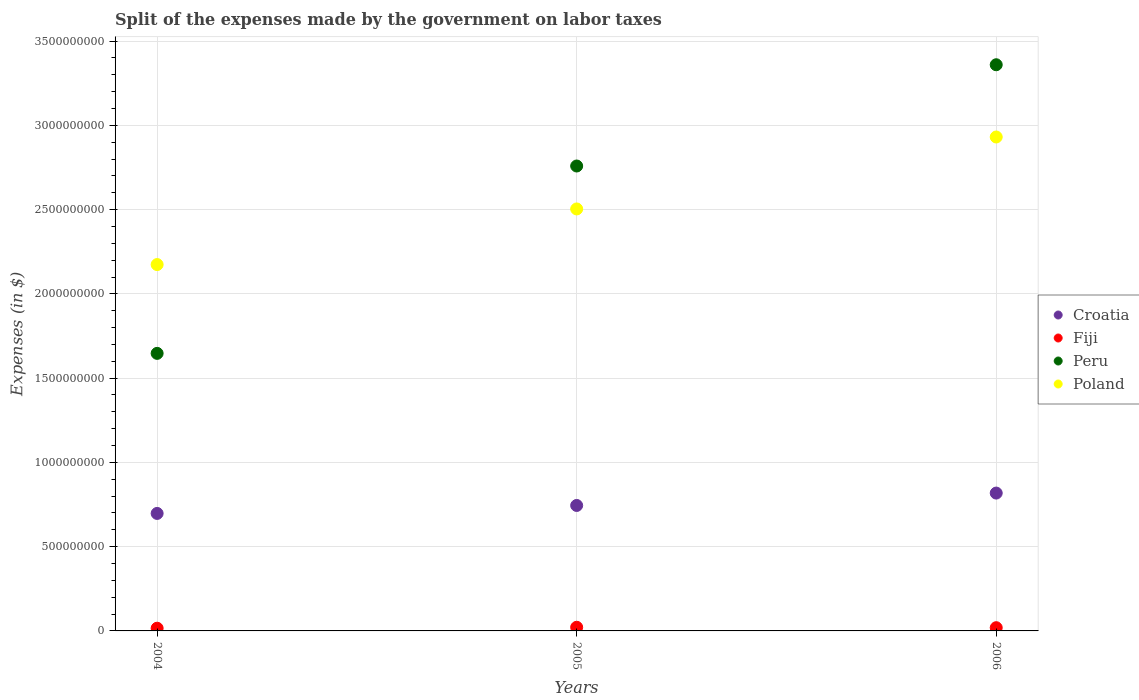How many different coloured dotlines are there?
Provide a succinct answer. 4. Is the number of dotlines equal to the number of legend labels?
Offer a terse response. Yes. What is the expenses made by the government on labor taxes in Peru in 2006?
Make the answer very short. 3.36e+09. Across all years, what is the maximum expenses made by the government on labor taxes in Poland?
Provide a short and direct response. 2.93e+09. Across all years, what is the minimum expenses made by the government on labor taxes in Croatia?
Provide a succinct answer. 6.97e+08. In which year was the expenses made by the government on labor taxes in Poland maximum?
Provide a succinct answer. 2006. What is the total expenses made by the government on labor taxes in Peru in the graph?
Provide a short and direct response. 7.77e+09. What is the difference between the expenses made by the government on labor taxes in Croatia in 2005 and that in 2006?
Your response must be concise. -7.35e+07. What is the difference between the expenses made by the government on labor taxes in Poland in 2004 and the expenses made by the government on labor taxes in Peru in 2005?
Give a very brief answer. -5.85e+08. What is the average expenses made by the government on labor taxes in Fiji per year?
Your answer should be very brief. 1.90e+07. In the year 2005, what is the difference between the expenses made by the government on labor taxes in Peru and expenses made by the government on labor taxes in Poland?
Your answer should be compact. 2.55e+08. In how many years, is the expenses made by the government on labor taxes in Poland greater than 1600000000 $?
Provide a short and direct response. 3. What is the ratio of the expenses made by the government on labor taxes in Poland in 2004 to that in 2006?
Your response must be concise. 0.74. Is the difference between the expenses made by the government on labor taxes in Peru in 2004 and 2006 greater than the difference between the expenses made by the government on labor taxes in Poland in 2004 and 2006?
Your response must be concise. No. What is the difference between the highest and the second highest expenses made by the government on labor taxes in Poland?
Ensure brevity in your answer.  4.27e+08. What is the difference between the highest and the lowest expenses made by the government on labor taxes in Fiji?
Your response must be concise. 5.63e+06. Does the expenses made by the government on labor taxes in Poland monotonically increase over the years?
Give a very brief answer. Yes. How many dotlines are there?
Make the answer very short. 4. What is the difference between two consecutive major ticks on the Y-axis?
Provide a succinct answer. 5.00e+08. Where does the legend appear in the graph?
Offer a terse response. Center right. How many legend labels are there?
Your response must be concise. 4. What is the title of the graph?
Offer a terse response. Split of the expenses made by the government on labor taxes. Does "Middle income" appear as one of the legend labels in the graph?
Make the answer very short. No. What is the label or title of the X-axis?
Provide a succinct answer. Years. What is the label or title of the Y-axis?
Your answer should be compact. Expenses (in $). What is the Expenses (in $) in Croatia in 2004?
Your response must be concise. 6.97e+08. What is the Expenses (in $) of Fiji in 2004?
Your response must be concise. 1.61e+07. What is the Expenses (in $) in Peru in 2004?
Your response must be concise. 1.65e+09. What is the Expenses (in $) of Poland in 2004?
Keep it short and to the point. 2.17e+09. What is the Expenses (in $) of Croatia in 2005?
Make the answer very short. 7.44e+08. What is the Expenses (in $) of Fiji in 2005?
Your answer should be very brief. 2.17e+07. What is the Expenses (in $) in Peru in 2005?
Your answer should be very brief. 2.76e+09. What is the Expenses (in $) of Poland in 2005?
Provide a short and direct response. 2.50e+09. What is the Expenses (in $) of Croatia in 2006?
Give a very brief answer. 8.18e+08. What is the Expenses (in $) in Fiji in 2006?
Your response must be concise. 1.92e+07. What is the Expenses (in $) in Peru in 2006?
Make the answer very short. 3.36e+09. What is the Expenses (in $) in Poland in 2006?
Make the answer very short. 2.93e+09. Across all years, what is the maximum Expenses (in $) of Croatia?
Your answer should be compact. 8.18e+08. Across all years, what is the maximum Expenses (in $) in Fiji?
Your answer should be very brief. 2.17e+07. Across all years, what is the maximum Expenses (in $) in Peru?
Offer a very short reply. 3.36e+09. Across all years, what is the maximum Expenses (in $) of Poland?
Provide a short and direct response. 2.93e+09. Across all years, what is the minimum Expenses (in $) in Croatia?
Ensure brevity in your answer.  6.97e+08. Across all years, what is the minimum Expenses (in $) of Fiji?
Offer a very short reply. 1.61e+07. Across all years, what is the minimum Expenses (in $) of Peru?
Keep it short and to the point. 1.65e+09. Across all years, what is the minimum Expenses (in $) of Poland?
Your answer should be compact. 2.17e+09. What is the total Expenses (in $) of Croatia in the graph?
Your answer should be compact. 2.26e+09. What is the total Expenses (in $) in Fiji in the graph?
Your response must be concise. 5.69e+07. What is the total Expenses (in $) of Peru in the graph?
Your answer should be compact. 7.77e+09. What is the total Expenses (in $) in Poland in the graph?
Keep it short and to the point. 7.61e+09. What is the difference between the Expenses (in $) of Croatia in 2004 and that in 2005?
Ensure brevity in your answer.  -4.73e+07. What is the difference between the Expenses (in $) of Fiji in 2004 and that in 2005?
Your response must be concise. -5.63e+06. What is the difference between the Expenses (in $) of Peru in 2004 and that in 2005?
Your answer should be very brief. -1.11e+09. What is the difference between the Expenses (in $) in Poland in 2004 and that in 2005?
Offer a terse response. -3.30e+08. What is the difference between the Expenses (in $) of Croatia in 2004 and that in 2006?
Offer a terse response. -1.21e+08. What is the difference between the Expenses (in $) of Fiji in 2004 and that in 2006?
Keep it short and to the point. -3.12e+06. What is the difference between the Expenses (in $) in Peru in 2004 and that in 2006?
Ensure brevity in your answer.  -1.71e+09. What is the difference between the Expenses (in $) of Poland in 2004 and that in 2006?
Provide a short and direct response. -7.57e+08. What is the difference between the Expenses (in $) of Croatia in 2005 and that in 2006?
Your answer should be very brief. -7.35e+07. What is the difference between the Expenses (in $) of Fiji in 2005 and that in 2006?
Make the answer very short. 2.51e+06. What is the difference between the Expenses (in $) of Peru in 2005 and that in 2006?
Provide a succinct answer. -6.01e+08. What is the difference between the Expenses (in $) in Poland in 2005 and that in 2006?
Give a very brief answer. -4.27e+08. What is the difference between the Expenses (in $) in Croatia in 2004 and the Expenses (in $) in Fiji in 2005?
Offer a very short reply. 6.76e+08. What is the difference between the Expenses (in $) in Croatia in 2004 and the Expenses (in $) in Peru in 2005?
Offer a terse response. -2.06e+09. What is the difference between the Expenses (in $) in Croatia in 2004 and the Expenses (in $) in Poland in 2005?
Your answer should be very brief. -1.81e+09. What is the difference between the Expenses (in $) of Fiji in 2004 and the Expenses (in $) of Peru in 2005?
Offer a terse response. -2.74e+09. What is the difference between the Expenses (in $) of Fiji in 2004 and the Expenses (in $) of Poland in 2005?
Provide a short and direct response. -2.49e+09. What is the difference between the Expenses (in $) of Peru in 2004 and the Expenses (in $) of Poland in 2005?
Provide a short and direct response. -8.57e+08. What is the difference between the Expenses (in $) in Croatia in 2004 and the Expenses (in $) in Fiji in 2006?
Provide a succinct answer. 6.78e+08. What is the difference between the Expenses (in $) in Croatia in 2004 and the Expenses (in $) in Peru in 2006?
Ensure brevity in your answer.  -2.66e+09. What is the difference between the Expenses (in $) in Croatia in 2004 and the Expenses (in $) in Poland in 2006?
Keep it short and to the point. -2.23e+09. What is the difference between the Expenses (in $) in Fiji in 2004 and the Expenses (in $) in Peru in 2006?
Offer a very short reply. -3.34e+09. What is the difference between the Expenses (in $) of Fiji in 2004 and the Expenses (in $) of Poland in 2006?
Give a very brief answer. -2.91e+09. What is the difference between the Expenses (in $) of Peru in 2004 and the Expenses (in $) of Poland in 2006?
Make the answer very short. -1.28e+09. What is the difference between the Expenses (in $) in Croatia in 2005 and the Expenses (in $) in Fiji in 2006?
Ensure brevity in your answer.  7.25e+08. What is the difference between the Expenses (in $) of Croatia in 2005 and the Expenses (in $) of Peru in 2006?
Offer a terse response. -2.62e+09. What is the difference between the Expenses (in $) of Croatia in 2005 and the Expenses (in $) of Poland in 2006?
Offer a terse response. -2.19e+09. What is the difference between the Expenses (in $) in Fiji in 2005 and the Expenses (in $) in Peru in 2006?
Make the answer very short. -3.34e+09. What is the difference between the Expenses (in $) in Fiji in 2005 and the Expenses (in $) in Poland in 2006?
Make the answer very short. -2.91e+09. What is the difference between the Expenses (in $) in Peru in 2005 and the Expenses (in $) in Poland in 2006?
Your answer should be compact. -1.72e+08. What is the average Expenses (in $) in Croatia per year?
Provide a succinct answer. 7.53e+08. What is the average Expenses (in $) in Fiji per year?
Ensure brevity in your answer.  1.90e+07. What is the average Expenses (in $) of Peru per year?
Provide a short and direct response. 2.59e+09. What is the average Expenses (in $) in Poland per year?
Provide a succinct answer. 2.54e+09. In the year 2004, what is the difference between the Expenses (in $) in Croatia and Expenses (in $) in Fiji?
Offer a terse response. 6.81e+08. In the year 2004, what is the difference between the Expenses (in $) in Croatia and Expenses (in $) in Peru?
Your answer should be very brief. -9.50e+08. In the year 2004, what is the difference between the Expenses (in $) of Croatia and Expenses (in $) of Poland?
Ensure brevity in your answer.  -1.48e+09. In the year 2004, what is the difference between the Expenses (in $) in Fiji and Expenses (in $) in Peru?
Keep it short and to the point. -1.63e+09. In the year 2004, what is the difference between the Expenses (in $) in Fiji and Expenses (in $) in Poland?
Give a very brief answer. -2.16e+09. In the year 2004, what is the difference between the Expenses (in $) in Peru and Expenses (in $) in Poland?
Ensure brevity in your answer.  -5.27e+08. In the year 2005, what is the difference between the Expenses (in $) in Croatia and Expenses (in $) in Fiji?
Give a very brief answer. 7.23e+08. In the year 2005, what is the difference between the Expenses (in $) in Croatia and Expenses (in $) in Peru?
Offer a very short reply. -2.01e+09. In the year 2005, what is the difference between the Expenses (in $) in Croatia and Expenses (in $) in Poland?
Offer a terse response. -1.76e+09. In the year 2005, what is the difference between the Expenses (in $) of Fiji and Expenses (in $) of Peru?
Keep it short and to the point. -2.74e+09. In the year 2005, what is the difference between the Expenses (in $) in Fiji and Expenses (in $) in Poland?
Your answer should be very brief. -2.48e+09. In the year 2005, what is the difference between the Expenses (in $) in Peru and Expenses (in $) in Poland?
Provide a short and direct response. 2.55e+08. In the year 2006, what is the difference between the Expenses (in $) of Croatia and Expenses (in $) of Fiji?
Your answer should be compact. 7.99e+08. In the year 2006, what is the difference between the Expenses (in $) in Croatia and Expenses (in $) in Peru?
Keep it short and to the point. -2.54e+09. In the year 2006, what is the difference between the Expenses (in $) in Croatia and Expenses (in $) in Poland?
Provide a short and direct response. -2.11e+09. In the year 2006, what is the difference between the Expenses (in $) in Fiji and Expenses (in $) in Peru?
Provide a short and direct response. -3.34e+09. In the year 2006, what is the difference between the Expenses (in $) in Fiji and Expenses (in $) in Poland?
Offer a terse response. -2.91e+09. In the year 2006, what is the difference between the Expenses (in $) in Peru and Expenses (in $) in Poland?
Ensure brevity in your answer.  4.29e+08. What is the ratio of the Expenses (in $) of Croatia in 2004 to that in 2005?
Provide a short and direct response. 0.94. What is the ratio of the Expenses (in $) in Fiji in 2004 to that in 2005?
Offer a very short reply. 0.74. What is the ratio of the Expenses (in $) in Peru in 2004 to that in 2005?
Your answer should be very brief. 0.6. What is the ratio of the Expenses (in $) in Poland in 2004 to that in 2005?
Offer a very short reply. 0.87. What is the ratio of the Expenses (in $) of Croatia in 2004 to that in 2006?
Keep it short and to the point. 0.85. What is the ratio of the Expenses (in $) in Fiji in 2004 to that in 2006?
Ensure brevity in your answer.  0.84. What is the ratio of the Expenses (in $) in Peru in 2004 to that in 2006?
Your response must be concise. 0.49. What is the ratio of the Expenses (in $) in Poland in 2004 to that in 2006?
Give a very brief answer. 0.74. What is the ratio of the Expenses (in $) in Croatia in 2005 to that in 2006?
Keep it short and to the point. 0.91. What is the ratio of the Expenses (in $) in Fiji in 2005 to that in 2006?
Your answer should be compact. 1.13. What is the ratio of the Expenses (in $) of Peru in 2005 to that in 2006?
Your answer should be very brief. 0.82. What is the ratio of the Expenses (in $) in Poland in 2005 to that in 2006?
Your answer should be compact. 0.85. What is the difference between the highest and the second highest Expenses (in $) in Croatia?
Provide a short and direct response. 7.35e+07. What is the difference between the highest and the second highest Expenses (in $) in Fiji?
Make the answer very short. 2.51e+06. What is the difference between the highest and the second highest Expenses (in $) in Peru?
Provide a short and direct response. 6.01e+08. What is the difference between the highest and the second highest Expenses (in $) of Poland?
Make the answer very short. 4.27e+08. What is the difference between the highest and the lowest Expenses (in $) in Croatia?
Keep it short and to the point. 1.21e+08. What is the difference between the highest and the lowest Expenses (in $) in Fiji?
Offer a very short reply. 5.63e+06. What is the difference between the highest and the lowest Expenses (in $) of Peru?
Offer a terse response. 1.71e+09. What is the difference between the highest and the lowest Expenses (in $) in Poland?
Keep it short and to the point. 7.57e+08. 